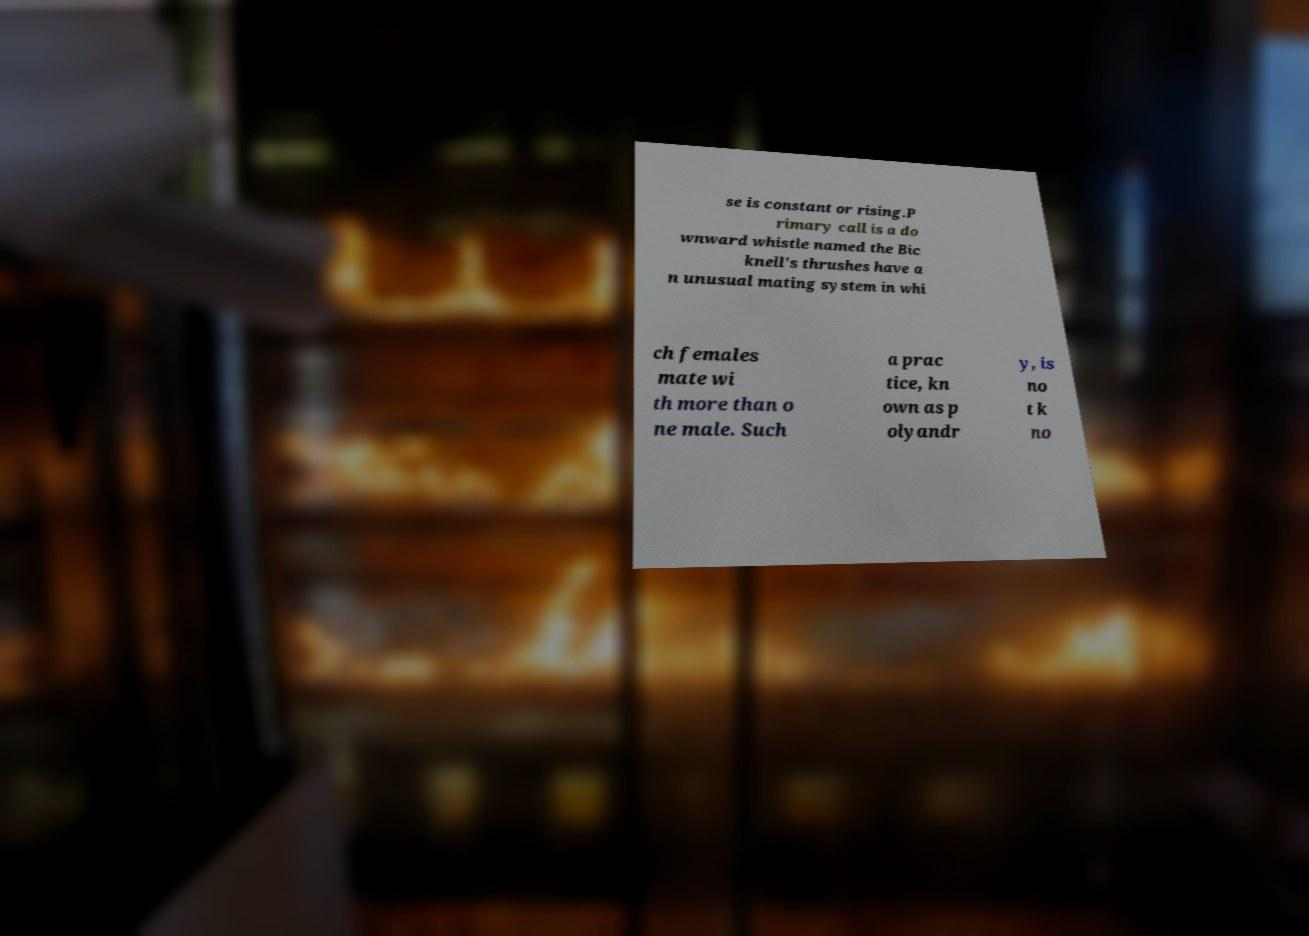I need the written content from this picture converted into text. Can you do that? se is constant or rising.P rimary call is a do wnward whistle named the Bic knell's thrushes have a n unusual mating system in whi ch females mate wi th more than o ne male. Such a prac tice, kn own as p olyandr y, is no t k no 